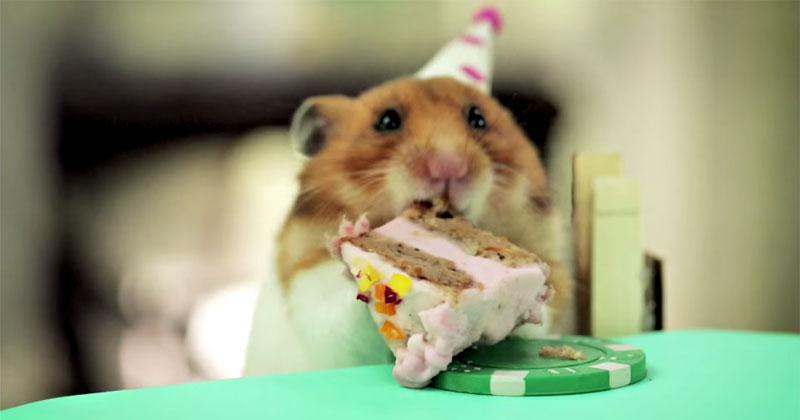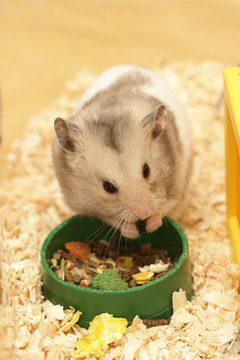The first image is the image on the left, the second image is the image on the right. Analyze the images presented: Is the assertion "An image shows a hamster eating at a green """"table"""" that holds a poker chip """"dish"""" with white notch marks around its edge." valid? Answer yes or no. Yes. 